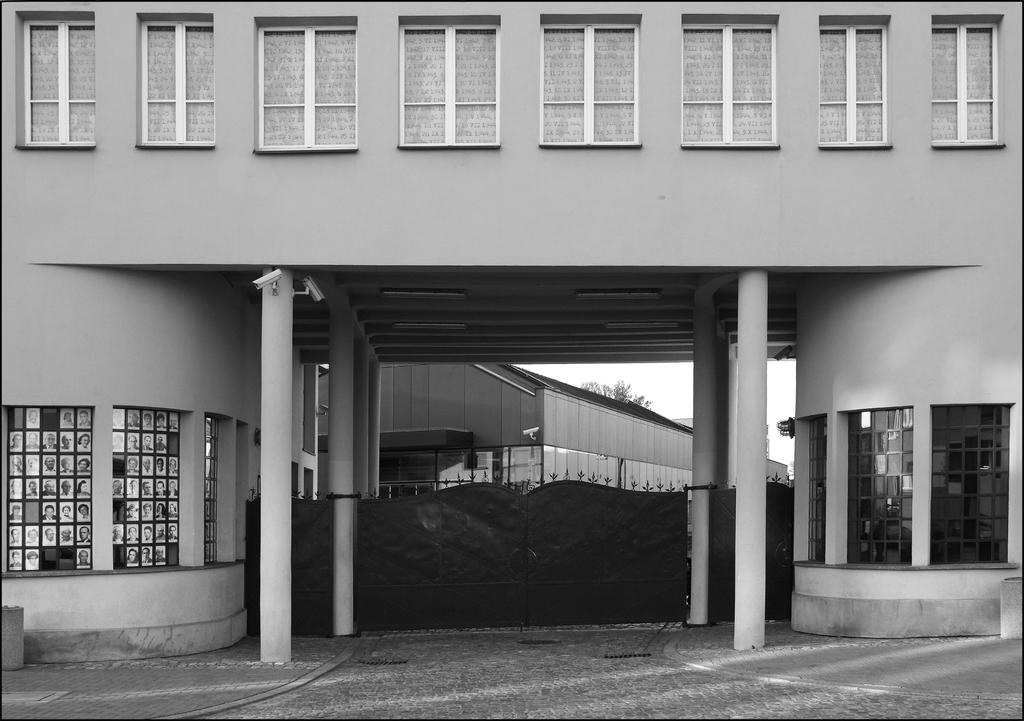What type of structure is present in the image? There is a building in the image. What are the main features of the building? The building has walls, windows, and pillars. Is there any entrance or exit associated with the building? Yes, there is a gate associated with the building. What can be seen in the background of the image? There is another building with walls in the background of the image. What type of cracker is being used to prop open the window in the image? There is no cracker present in the image, nor is there any indication that a window is being propped open. 